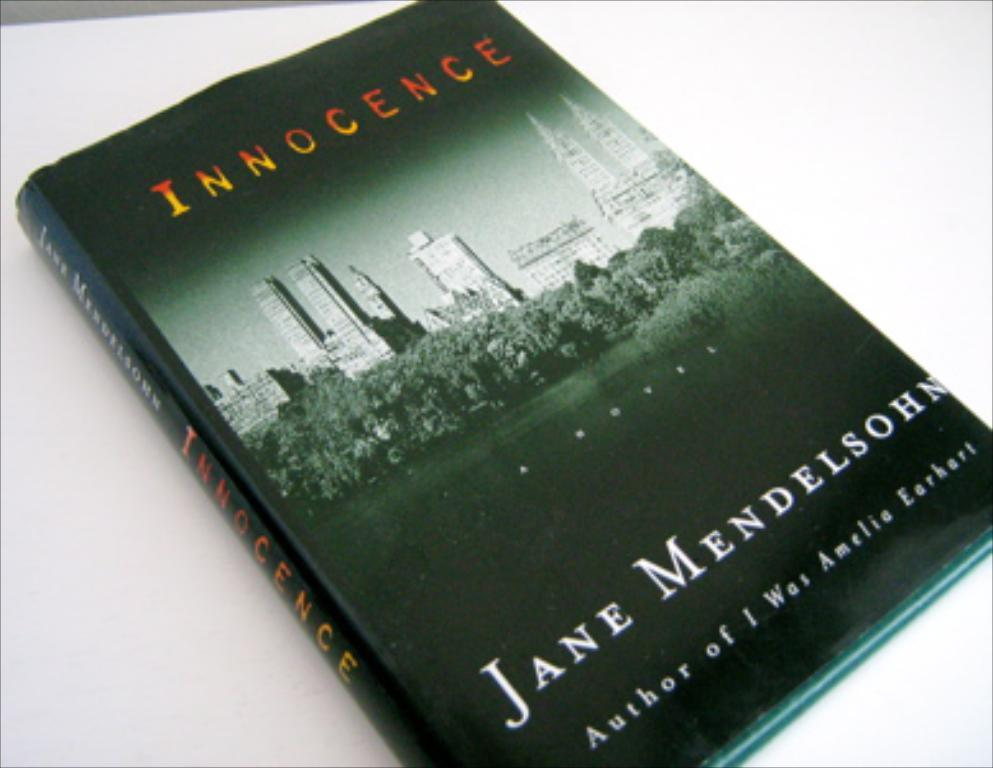<image>
Summarize the visual content of the image. A book called Innocence by author Jane Mendelsohn. 